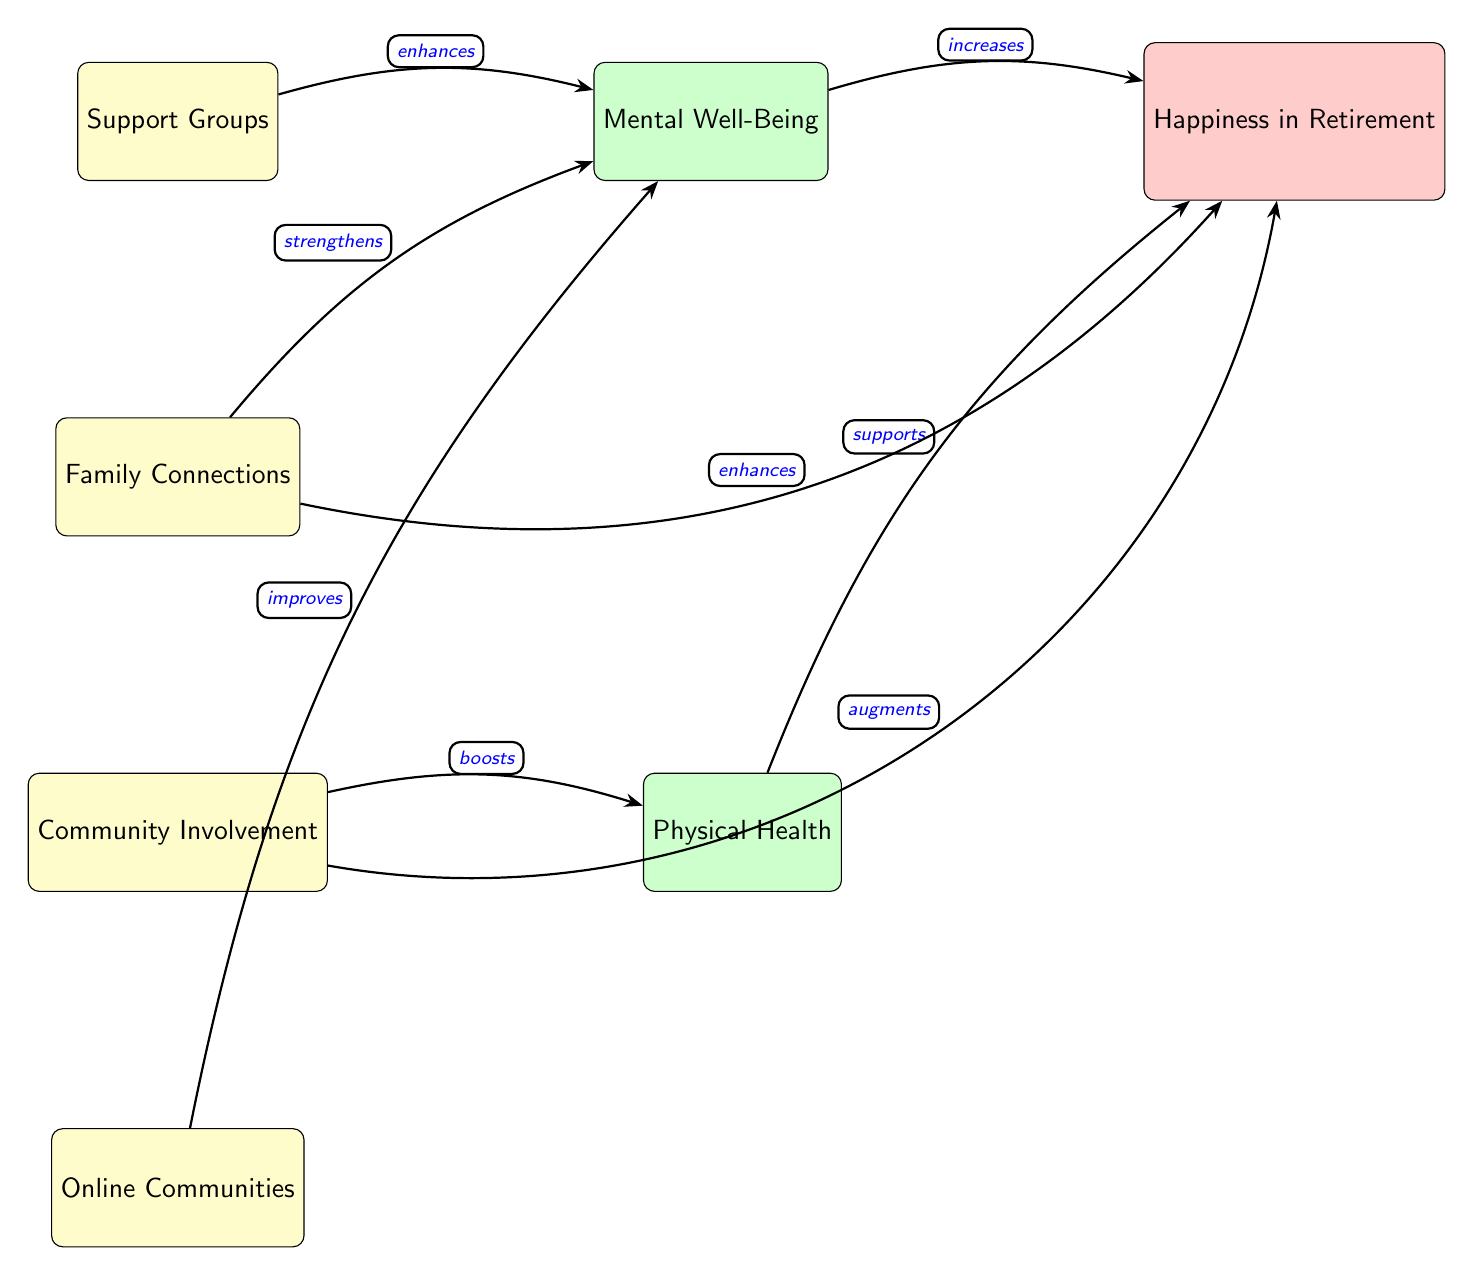What are the four types of support systems depicted in the diagram? The diagram lists four support systems: Support Groups, Family Connections, Community Involvement, and Online Communities. These can be identified as the nodes at the left side of the diagram.
Answer: Support Groups, Family Connections, Community Involvement, Online Communities Which support system is directly connected to Mental Well-Being? There are four support systems, but only Support Groups, Family Connections, and Online Communities have direct connections to Mental Well-Being. Among them, Support Groups is listed first, allowing us to answer based on the first connection shown.
Answer: Support Groups How many edges are there in the diagram? Counting the directed relationships (arrows) shown in the diagram results in a total of six edges connecting the nodes.
Answer: 6 What enhances Mental Well-Being according to the diagram? The diagram indicates that Support Groups and Family Connections both are labeled as "enhances" connections to Mental Well-Being. By reviewing the arrows, we can confirm the answer.
Answer: Support Groups, Family Connections Which two elements directly influence Happiness in Retirement? The diagram shows that both Mental Well-Being and Physical Health are directly linked to Happiness in Retirement, each influencing it positively according to the relationships illustrated.
Answer: Mental Well-Being, Physical Health What role does Community Involvement play in relation to Physical Health? The diagram shows a direct connection from Community Involvement to Physical Health, labeled with the word "boosts". This detail indicates that Community Involvement has a positive effect on Physical Health.
Answer: boosts Which support system directly improves Mental Well-Being? The diagram shows that Online Communities is directly connected to Mental Well-Being with the label "improves", highlighting its positive impact on this aspect.
Answer: Online Communities How does Family Connections relate to Happiness in Retirement? The diagram delineates Family Connections as having the effect of "enhances" on Happiness in Retirement, making it clear that it has a positive influence on happiness.
Answer: enhances What is the relationship between Physical Health and Happiness in Retirement? The diagram indicates that Physical Health is linked to Happiness in Retirement with the label "supports", meaning that better physical health contributes positively to happiness in retirement.
Answer: supports 